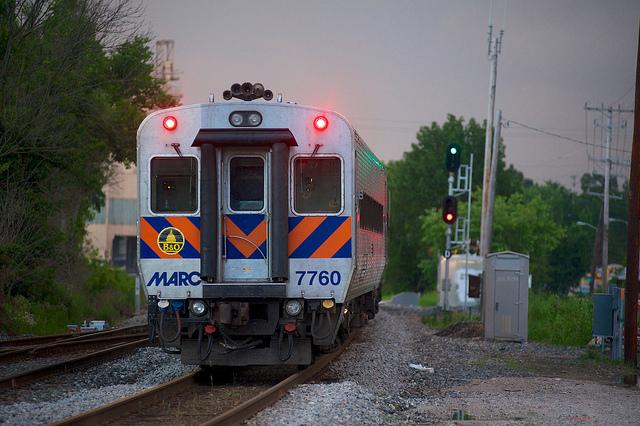What is beneath the tracks?
Concise answer only. Gravel. What color is the train?
Write a very short answer. White. What number is on the left train?
Give a very brief answer. 7760. What is the no written on the train?
Keep it brief. 7760. How many people are on the train?
Quick response, please. 1. How many trains are shown?
Concise answer only. 1. What number is on the train?
Keep it brief. 7760. 